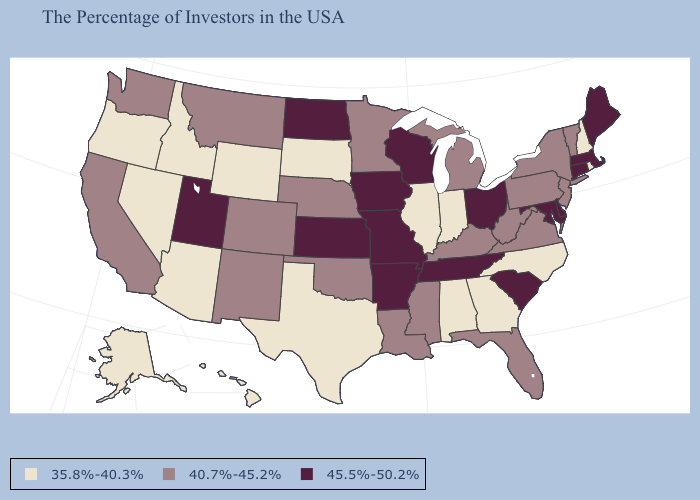What is the value of Ohio?
Write a very short answer. 45.5%-50.2%. Which states have the lowest value in the Northeast?
Short answer required. Rhode Island, New Hampshire. Among the states that border Maryland , which have the highest value?
Write a very short answer. Delaware. Name the states that have a value in the range 40.7%-45.2%?
Answer briefly. Vermont, New York, New Jersey, Pennsylvania, Virginia, West Virginia, Florida, Michigan, Kentucky, Mississippi, Louisiana, Minnesota, Nebraska, Oklahoma, Colorado, New Mexico, Montana, California, Washington. Does Washington have the highest value in the USA?
Quick response, please. No. What is the value of Pennsylvania?
Be succinct. 40.7%-45.2%. Which states have the lowest value in the West?
Be succinct. Wyoming, Arizona, Idaho, Nevada, Oregon, Alaska, Hawaii. Does Ohio have the highest value in the USA?
Write a very short answer. Yes. What is the value of Nevada?
Short answer required. 35.8%-40.3%. Name the states that have a value in the range 40.7%-45.2%?
Short answer required. Vermont, New York, New Jersey, Pennsylvania, Virginia, West Virginia, Florida, Michigan, Kentucky, Mississippi, Louisiana, Minnesota, Nebraska, Oklahoma, Colorado, New Mexico, Montana, California, Washington. Does the map have missing data?
Short answer required. No. What is the lowest value in the USA?
Write a very short answer. 35.8%-40.3%. What is the value of Georgia?
Concise answer only. 35.8%-40.3%. Which states have the lowest value in the Northeast?
Give a very brief answer. Rhode Island, New Hampshire. Does Connecticut have the highest value in the Northeast?
Answer briefly. Yes. 